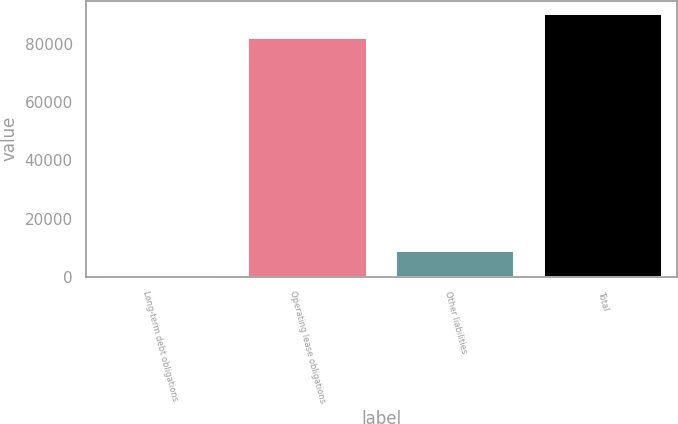Convert chart. <chart><loc_0><loc_0><loc_500><loc_500><bar_chart><fcel>Long-term debt obligations<fcel>Operating lease obligations<fcel>Other liabilities<fcel>Total<nl><fcel>505<fcel>82101<fcel>8807.6<fcel>90403.6<nl></chart> 